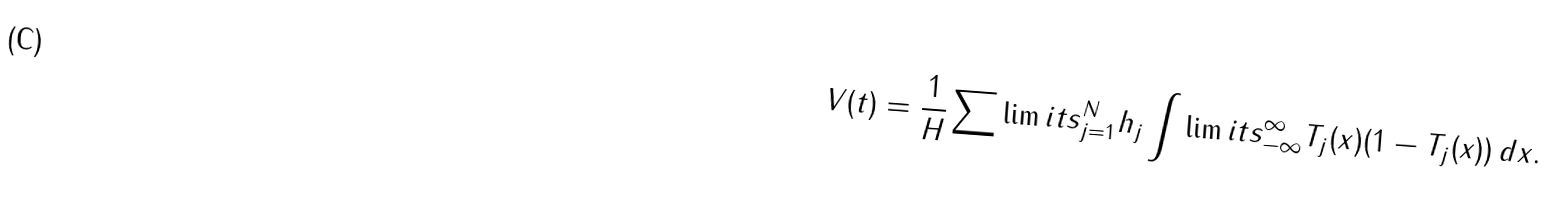<formula> <loc_0><loc_0><loc_500><loc_500>V ( t ) = \frac { 1 } { H } \sum \lim i t s _ { j = 1 } ^ { N } h _ { j } \int \lim i t s _ { - \infty } ^ { \infty } T _ { j } ( x ) ( 1 - T _ { j } ( x ) ) \, d x .</formula> 